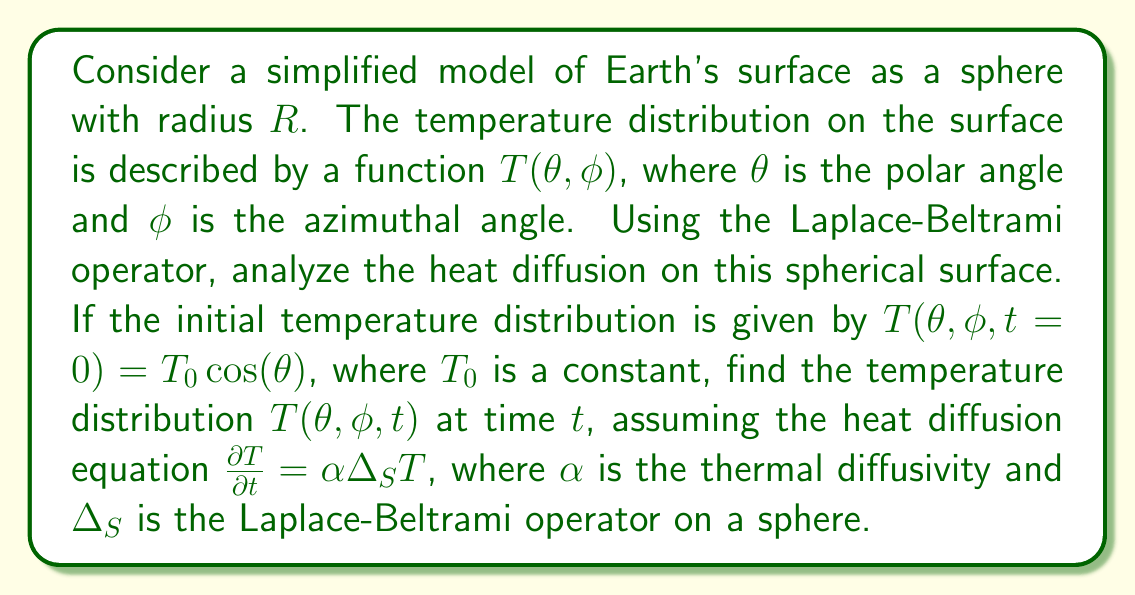Help me with this question. To solve this problem, we'll follow these steps:

1) The Laplace-Beltrami operator on a sphere of radius $R$ in spherical coordinates is:

   $$\Delta_S = \frac{1}{R^2 \sin\theta} \frac{\partial}{\partial \theta}\left(\sin\theta \frac{\partial}{\partial \theta}\right) + \frac{1}{R^2 \sin^2\theta} \frac{\partial^2}{\partial \phi^2}$$

2) The heat diffusion equation on the sphere is:

   $$\frac{\partial T}{\partial t} = \alpha \Delta_S T$$

3) Given the initial condition $T(\theta, \phi, t=0) = T_0 \cos(\theta)$, we can assume that the solution will not depend on $\phi$ due to the symmetry of the initial condition. Thus, we can simplify our equation to:

   $$\frac{\partial T}{\partial t} = \frac{\alpha}{R^2 \sin\theta} \frac{\partial}{\partial \theta}\left(\sin\theta \frac{\partial T}{\partial \theta}\right)$$

4) We can separate variables by assuming a solution of the form $T(\theta, t) = \Theta(\theta)f(t)$. Substituting this into our equation:

   $$\Theta(\theta)\frac{df}{dt} = \frac{\alpha f(t)}{R^2 \sin\theta} \frac{d}{d\theta}\left(\sin\theta \frac{d\Theta}{d\theta}\right)$$

5) Dividing both sides by $\Theta(\theta)f(t)$:

   $$\frac{1}{f}\frac{df}{dt} = \frac{\alpha}{R^2 \Theta \sin\theta} \frac{d}{d\theta}\left(\sin\theta \frac{d\Theta}{d\theta}\right) = -\lambda$$

   Where $\lambda$ is a separation constant.

6) This gives us two equations:
   
   $$\frac{df}{dt} = -\lambda \alpha f$$
   $$\frac{1}{\sin\theta} \frac{d}{d\theta}\left(\sin\theta \frac{d\Theta}{d\theta}\right) + \lambda R^2 \Theta = 0$$

7) The second equation is the Legendre equation, whose solutions are the Legendre polynomials $P_n(\cos\theta)$ with $\lambda = n(n+1)/R^2$.

8) The solution to the time equation is $f(t) = e^{-\alpha n(n+1)t/R^2}$.

9) Given our initial condition, we know that $n=1$ (as $\cos\theta$ is the first Legendre polynomial $P_1(\cos\theta)$).

10) Therefore, the full solution is:

    $$T(\theta, t) = T_0 \cos(\theta) e^{-2\alpha t/R^2}$$

This solution represents how the initial temperature distribution diffuses over time on the spherical surface of the Earth.
Answer: $T(\theta, t) = T_0 \cos(\theta) e^{-2\alpha t/R^2}$ 